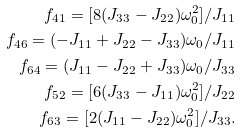Convert formula to latex. <formula><loc_0><loc_0><loc_500><loc_500>f _ { 4 1 } = [ 8 ( J _ { 3 3 } - J _ { 2 2 } ) \omega _ { 0 } ^ { 2 } ] / J _ { 1 1 } \\ f _ { 4 6 } = ( - J _ { 1 1 } + J _ { 2 2 } - J _ { 3 3 } ) \omega _ { 0 } / J _ { 1 1 } \\ f _ { 6 4 } = ( J _ { 1 1 } - J _ { 2 2 } + J _ { 3 3 } ) \omega _ { 0 } / J _ { 3 3 } \\ f _ { 5 2 } = [ 6 ( J _ { 3 3 } - J _ { 1 1 } ) \omega _ { 0 } ^ { 2 } ] / J _ { 2 2 } \\ f _ { 6 3 } = [ 2 ( J _ { 1 1 } - J _ { 2 2 } ) \omega _ { 0 } ^ { 2 } ] / J _ { 3 3 } .</formula> 